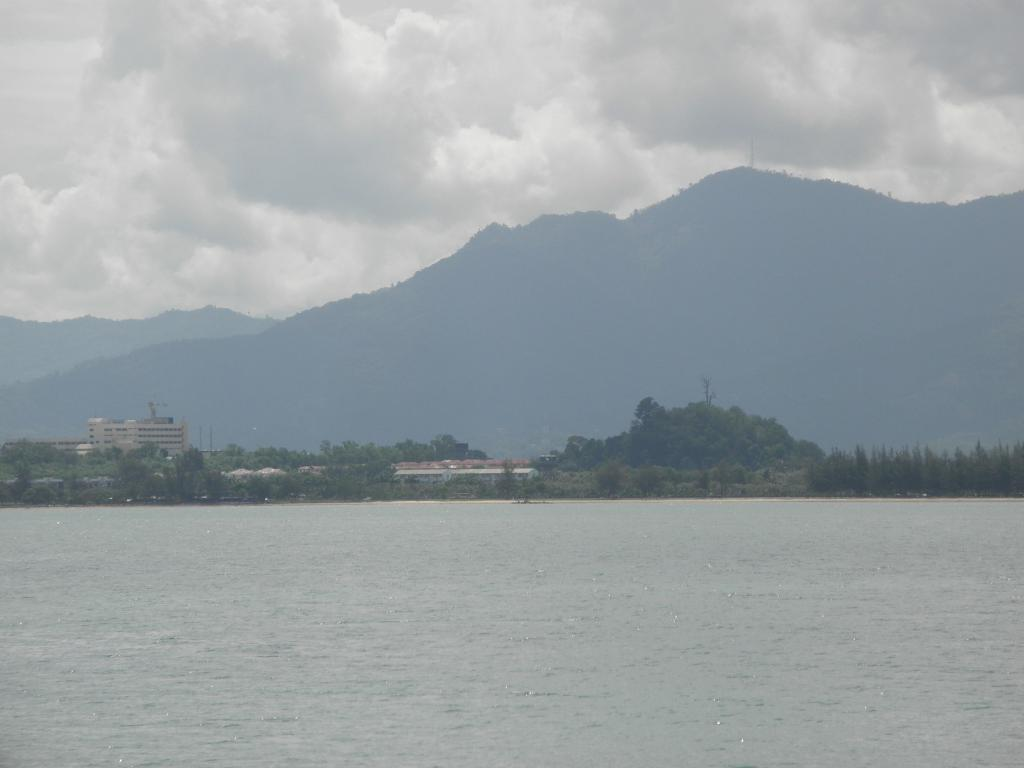What is the primary element visible in the image? The image contains a water surface. What type of vegetation can be seen in the image? There are trees visible in the image. What type of structures are present in the image? There are buildings in the image. What natural feature is visible in the background of the image? Mountains are present in the background of the image. What is visible in the sky at the top of the image? Clouds are visible in the sky at the top of the image. What type of secretary can be seen working near the water surface in the image? There is no secretary present in the image; it features a water surface, trees, buildings, mountains, and clouds. How many ducks are swimming in the water surface in the image? There are no ducks present in the image; it features a water surface, trees, buildings, mountains, and clouds. 